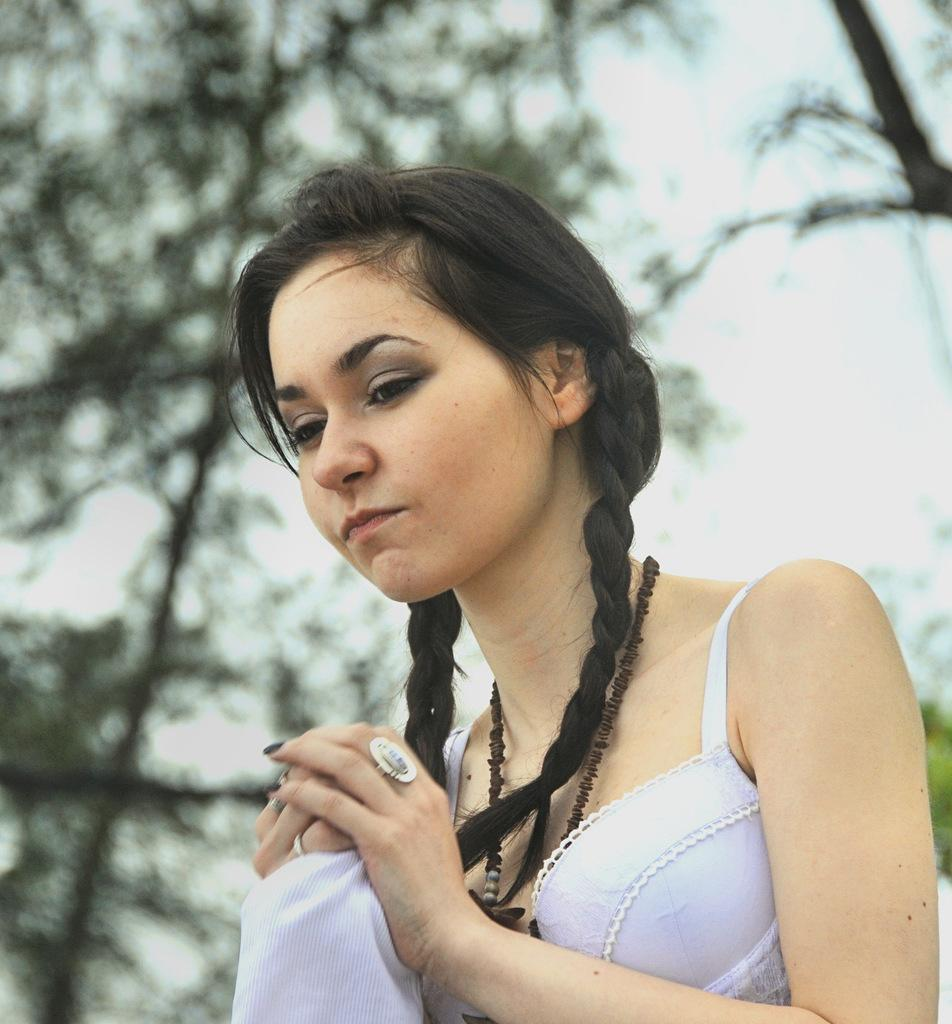Who is the main subject in the image? There is a woman in the image. What is the woman holding in her hands? The woman is holding a cloth in her hands. What can be seen in the background of the image? There are trees and the sky visible in the background of the image. How would you describe the background of the image? The background appears blurry. What type of cake is the woman regretting in the image? There is no cake present in the image, and the woman is not expressing any regret. 